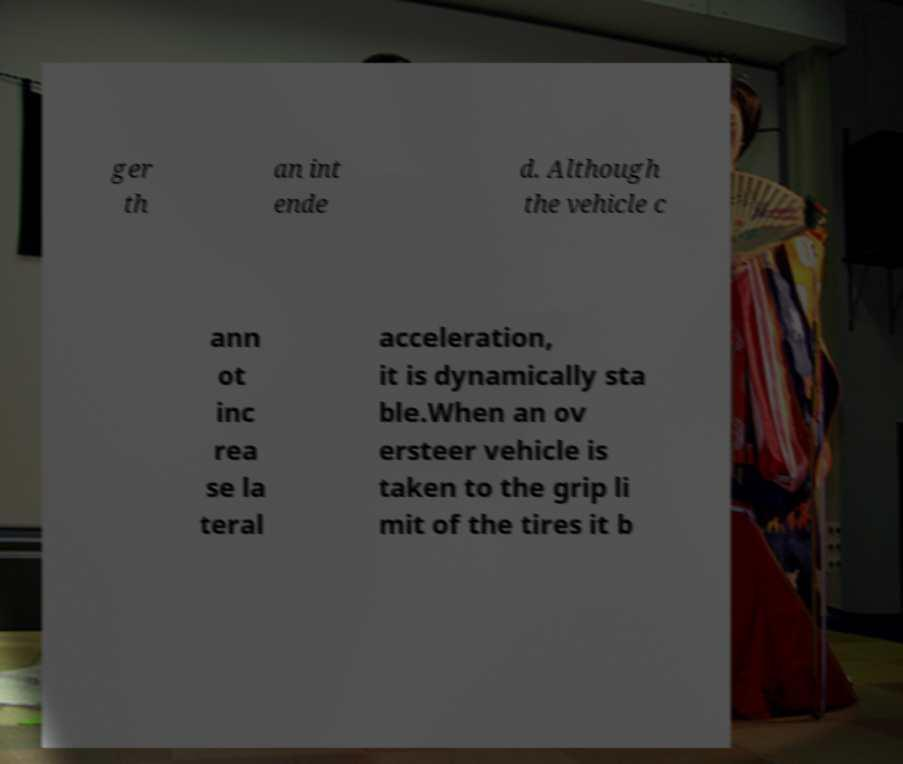Could you assist in decoding the text presented in this image and type it out clearly? ger th an int ende d. Although the vehicle c ann ot inc rea se la teral acceleration, it is dynamically sta ble.When an ov ersteer vehicle is taken to the grip li mit of the tires it b 